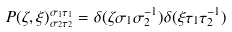<formula> <loc_0><loc_0><loc_500><loc_500>P ( \zeta , \xi ) _ { \sigma _ { 2 } \tau _ { 2 } } ^ { \sigma _ { 1 } \tau _ { 1 } } = \delta ( \zeta \sigma _ { 1 } \sigma _ { 2 } ^ { - 1 } ) \delta ( \xi \tau _ { 1 } \tau _ { 2 } ^ { - 1 } )</formula> 